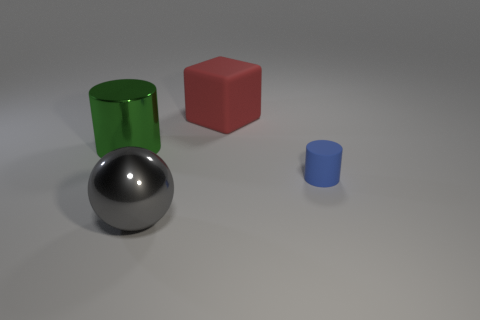There is a cylinder that is on the right side of the gray shiny sphere; how big is it?
Offer a very short reply. Small. There is a object that is on the right side of the red cube; is its size the same as the cylinder that is left of the big red block?
Provide a succinct answer. No. What number of other green cylinders have the same material as the big cylinder?
Offer a terse response. 0. What is the color of the rubber cylinder?
Provide a short and direct response. Blue. Are there any tiny blue cylinders on the right side of the big green cylinder?
Make the answer very short. Yes. What number of matte cubes are the same color as the small rubber cylinder?
Ensure brevity in your answer.  0. There is a thing that is on the right side of the big thing to the right of the large gray ball; how big is it?
Give a very brief answer. Small. There is a large red rubber object; what shape is it?
Provide a succinct answer. Cube. What material is the object that is behind the large green metallic object?
Make the answer very short. Rubber. What is the color of the matte thing in front of the cylinder to the left of the large thing that is on the right side of the gray shiny ball?
Your response must be concise. Blue. 